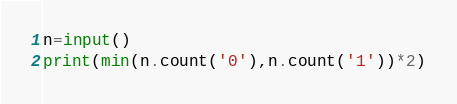<code> <loc_0><loc_0><loc_500><loc_500><_Python_>n=input()
print(min(n.count('0'),n.count('1'))*2)</code> 